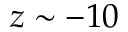<formula> <loc_0><loc_0><loc_500><loc_500>z \sim - 1 0</formula> 